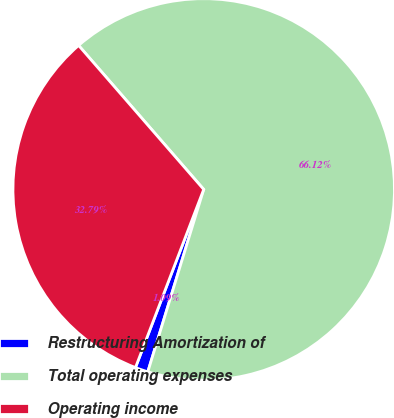<chart> <loc_0><loc_0><loc_500><loc_500><pie_chart><fcel>Restructuring Amortization of<fcel>Total operating expenses<fcel>Operating income<nl><fcel>1.09%<fcel>66.11%<fcel>32.79%<nl></chart> 